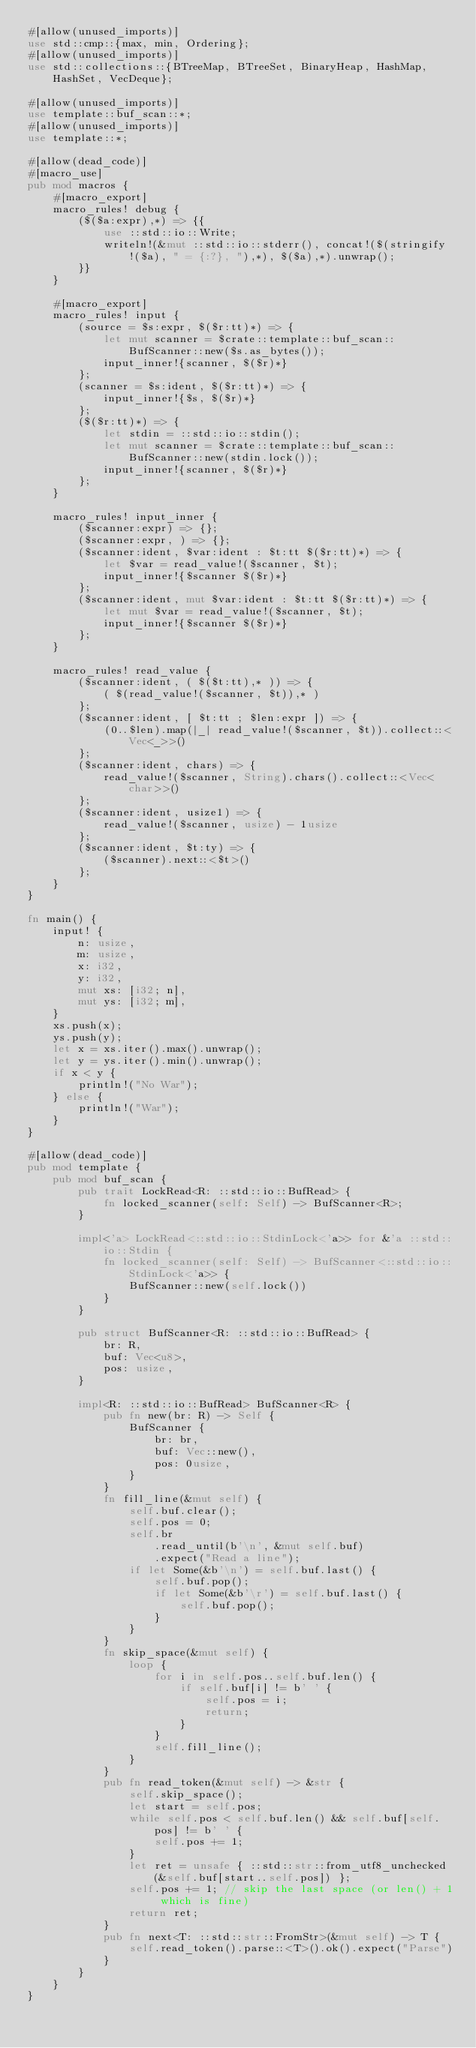Convert code to text. <code><loc_0><loc_0><loc_500><loc_500><_Rust_>#[allow(unused_imports)]
use std::cmp::{max, min, Ordering};
#[allow(unused_imports)]
use std::collections::{BTreeMap, BTreeSet, BinaryHeap, HashMap, HashSet, VecDeque};

#[allow(unused_imports)]
use template::buf_scan::*;
#[allow(unused_imports)]
use template::*;

#[allow(dead_code)]
#[macro_use]
pub mod macros {
    #[macro_export]
    macro_rules! debug {
        ($($a:expr),*) => {{
            use ::std::io::Write;
            writeln!(&mut ::std::io::stderr(), concat!($(stringify!($a), " = {:?}, "),*), $($a),*).unwrap();
        }}
    }

    #[macro_export]
    macro_rules! input {
        (source = $s:expr, $($r:tt)*) => {
            let mut scanner = $crate::template::buf_scan::BufScanner::new($s.as_bytes());
            input_inner!{scanner, $($r)*}
        };
        (scanner = $s:ident, $($r:tt)*) => {
            input_inner!{$s, $($r)*}
        };
        ($($r:tt)*) => {
            let stdin = ::std::io::stdin();
            let mut scanner = $crate::template::buf_scan::BufScanner::new(stdin.lock());
            input_inner!{scanner, $($r)*}
        };
    }

    macro_rules! input_inner {
        ($scanner:expr) => {};
        ($scanner:expr, ) => {};
        ($scanner:ident, $var:ident : $t:tt $($r:tt)*) => {
            let $var = read_value!($scanner, $t);
            input_inner!{$scanner $($r)*}
        };
        ($scanner:ident, mut $var:ident : $t:tt $($r:tt)*) => {
            let mut $var = read_value!($scanner, $t);
            input_inner!{$scanner $($r)*}
        };
    }

    macro_rules! read_value {
        ($scanner:ident, ( $($t:tt),* )) => {
            ( $(read_value!($scanner, $t)),* )
        };
        ($scanner:ident, [ $t:tt ; $len:expr ]) => {
            (0..$len).map(|_| read_value!($scanner, $t)).collect::<Vec<_>>()
        };
        ($scanner:ident, chars) => {
            read_value!($scanner, String).chars().collect::<Vec<char>>()
        };
        ($scanner:ident, usize1) => {
            read_value!($scanner, usize) - 1usize
        };
        ($scanner:ident, $t:ty) => {
            ($scanner).next::<$t>()
        };
    }
}

fn main() {
    input! {
        n: usize,
        m: usize,
        x: i32,
        y: i32,
        mut xs: [i32; n],
        mut ys: [i32; m],
    }
    xs.push(x);
    ys.push(y);
    let x = xs.iter().max().unwrap();
    let y = ys.iter().min().unwrap();
    if x < y {
        println!("No War");
    } else {
        println!("War");
    }
}

#[allow(dead_code)]
pub mod template {
    pub mod buf_scan {
        pub trait LockRead<R: ::std::io::BufRead> {
            fn locked_scanner(self: Self) -> BufScanner<R>;
        }

        impl<'a> LockRead<::std::io::StdinLock<'a>> for &'a ::std::io::Stdin {
            fn locked_scanner(self: Self) -> BufScanner<::std::io::StdinLock<'a>> {
                BufScanner::new(self.lock())
            }
        }

        pub struct BufScanner<R: ::std::io::BufRead> {
            br: R,
            buf: Vec<u8>,
            pos: usize,
        }

        impl<R: ::std::io::BufRead> BufScanner<R> {
            pub fn new(br: R) -> Self {
                BufScanner {
                    br: br,
                    buf: Vec::new(),
                    pos: 0usize,
                }
            }
            fn fill_line(&mut self) {
                self.buf.clear();
                self.pos = 0;
                self.br
                    .read_until(b'\n', &mut self.buf)
                    .expect("Read a line");
                if let Some(&b'\n') = self.buf.last() {
                    self.buf.pop();
                    if let Some(&b'\r') = self.buf.last() {
                        self.buf.pop();
                    }
                }
            }
            fn skip_space(&mut self) {
                loop {
                    for i in self.pos..self.buf.len() {
                        if self.buf[i] != b' ' {
                            self.pos = i;
                            return;
                        }
                    }
                    self.fill_line();
                }
            }
            pub fn read_token(&mut self) -> &str {
                self.skip_space();
                let start = self.pos;
                while self.pos < self.buf.len() && self.buf[self.pos] != b' ' {
                    self.pos += 1;
                }
                let ret = unsafe { ::std::str::from_utf8_unchecked(&self.buf[start..self.pos]) };
                self.pos += 1; // skip the last space (or len() + 1 which is fine)
                return ret;
            }
            pub fn next<T: ::std::str::FromStr>(&mut self) -> T {
                self.read_token().parse::<T>().ok().expect("Parse")
            }
        }
    }
}
</code> 